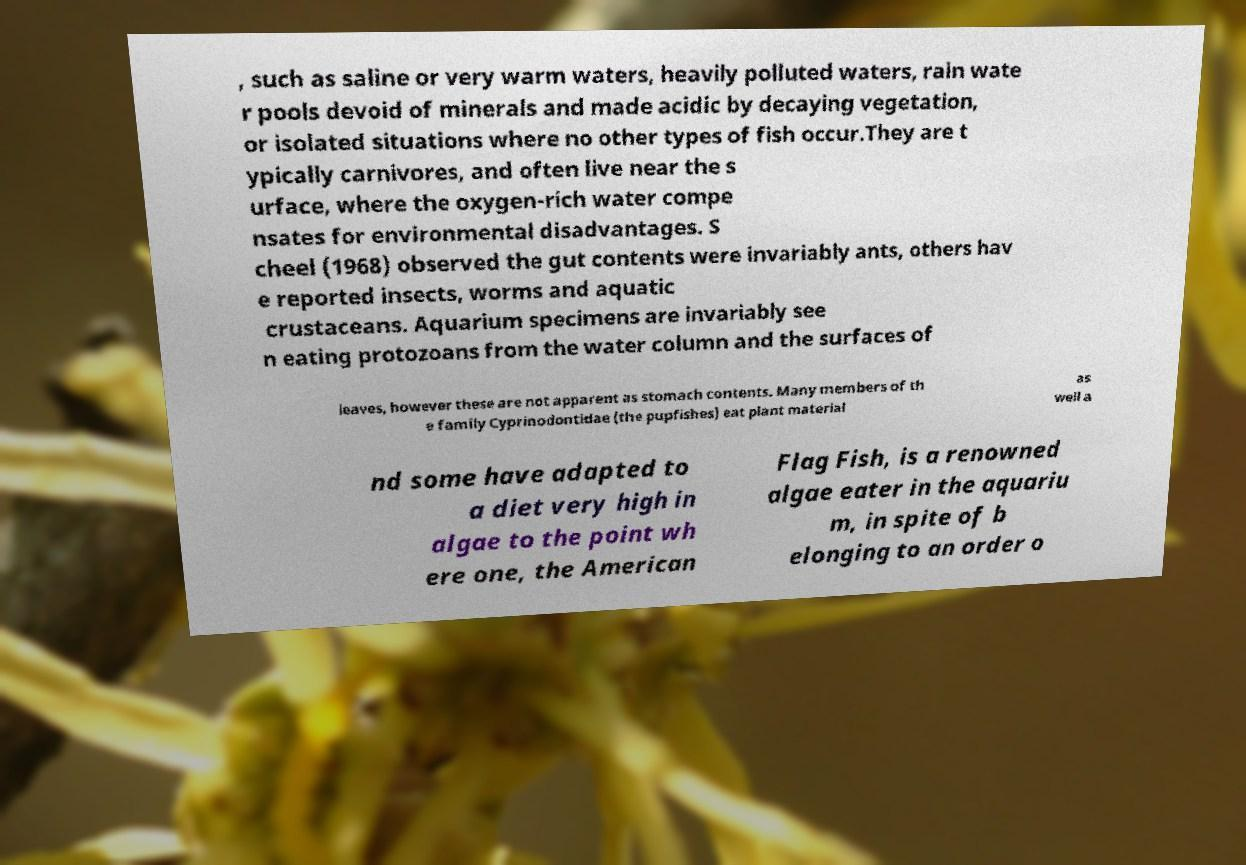I need the written content from this picture converted into text. Can you do that? , such as saline or very warm waters, heavily polluted waters, rain wate r pools devoid of minerals and made acidic by decaying vegetation, or isolated situations where no other types of fish occur.They are t ypically carnivores, and often live near the s urface, where the oxygen-rich water compe nsates for environmental disadvantages. S cheel (1968) observed the gut contents were invariably ants, others hav e reported insects, worms and aquatic crustaceans. Aquarium specimens are invariably see n eating protozoans from the water column and the surfaces of leaves, however these are not apparent as stomach contents. Many members of th e family Cyprinodontidae (the pupfishes) eat plant material as well a nd some have adapted to a diet very high in algae to the point wh ere one, the American Flag Fish, is a renowned algae eater in the aquariu m, in spite of b elonging to an order o 